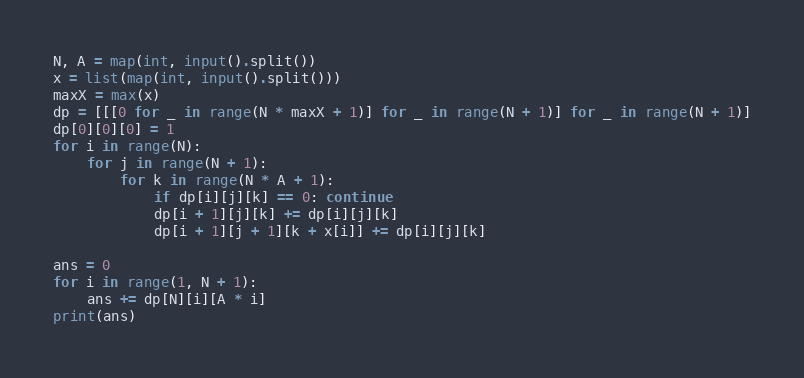<code> <loc_0><loc_0><loc_500><loc_500><_Python_>N, A = map(int, input().split())
x = list(map(int, input().split()))
maxX = max(x)
dp = [[[0 for _ in range(N * maxX + 1)] for _ in range(N + 1)] for _ in range(N + 1)]
dp[0][0][0] = 1
for i in range(N):
    for j in range(N + 1):
        for k in range(N * A + 1):
            if dp[i][j][k] == 0: continue
            dp[i + 1][j][k] += dp[i][j][k]
            dp[i + 1][j + 1][k + x[i]] += dp[i][j][k]

ans = 0
for i in range(1, N + 1):
    ans += dp[N][i][A * i]
print(ans)</code> 